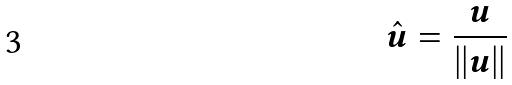<formula> <loc_0><loc_0><loc_500><loc_500>\hat { u } = \frac { u } { | | u | | }</formula> 